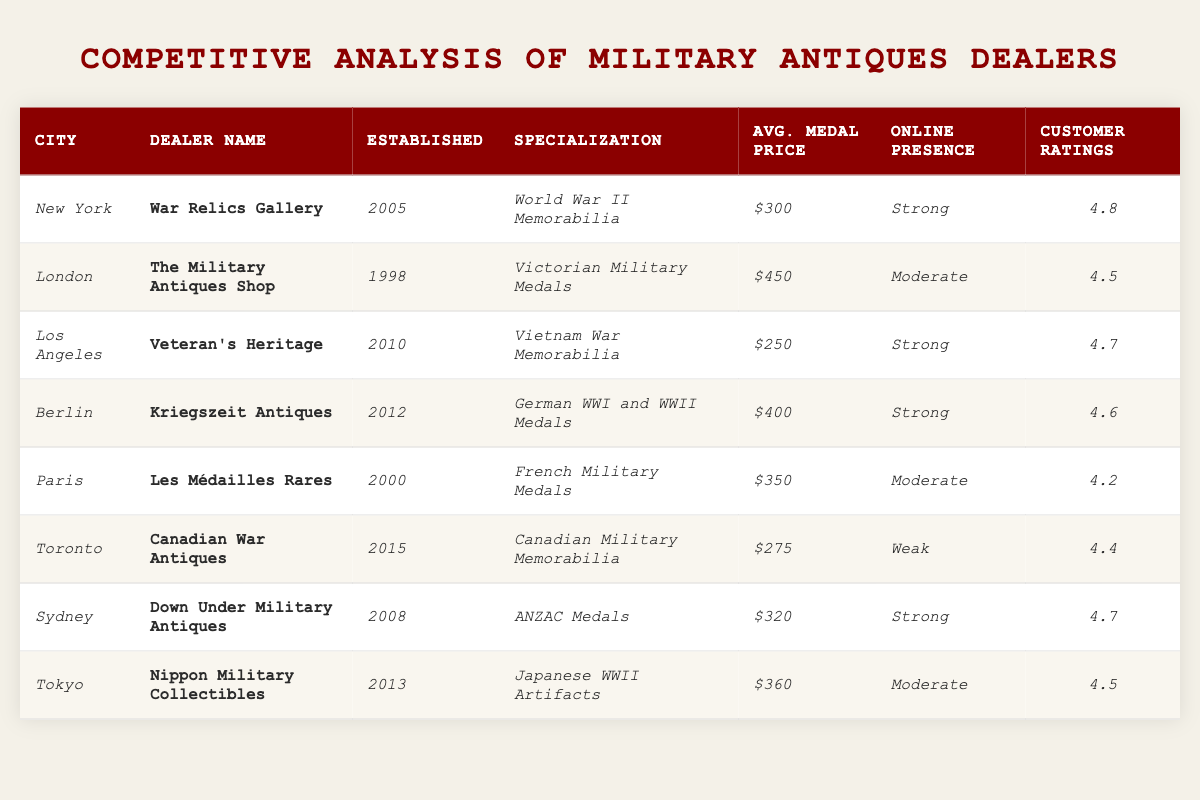What is the average price of medals across all dealers listed? To find the average price, first, we sum the average prices of all dealers: $300 + $450 + $250 + $400 + $350 + $275 + $320 + $360 = $2,685. Then, we divide this by the total number of dealers (8): $2,685 / 8 = $335.625, rounded to $336 when expressed in whole dollars.
Answer: $336 Which dealer has the highest customer ratings? By examining the customer ratings given for each dealer, we see that the highest rating is 4.8, which belongs to the War Relics Gallery in New York.
Answer: War Relics Gallery Is there a dealer specialized in Canadian Military Memorabilia? Yes, according to the table, the dealer specializing in Canadian Military Memorabilia is the Canadian War Antiques based in Toronto.
Answer: Yes How many dealers have a strong online presence? By counting the entries under the "Online Presence" column that mention "strong," we find that four dealers have a strong online presence: War Relics Gallery, Veteran's Heritage, Kriegszeit Antiques, and Down Under Military Antiques.
Answer: 4 Which city has the highest average medal price, and what is that price? Looking through the average prices, we find that London has the highest average medal price at $450 (as listed under The Military Antiques Shop).
Answer: London, $450 What is the difference in average medal prices between the highest and lowest priced medals? The highest average price is $450 from The Military Antiques Shop, and the lowest average price is $250 from Veteran's Heritage. The difference is calculated as $450 - $250 = $200.
Answer: $200 Which dealer was established most recently? By comparing the establishments dates, Canadian War Antiques was established in 2015, making it the most recently established dealer in the list.
Answer: Canadian War Antiques In which city does the dealer with the lowest average medal price operate? The dealer with the lowest average medal price is Veteran's Heritage with a price of $250, located in Los Angeles.
Answer: Los Angeles How many dealers have customer ratings of 4.5 or higher? We check the customer ratings and note those 4.5 or higher: War Relics Gallery (4.8), Veteran's Heritage (4.7), Kriegszeit Antiques (4.6), The Military Antiques Shop (4.5), and Nippon Military Collectibles (4.5). This gives us a total of five dealers.
Answer: 5 Which specialization is most commonly found among the dealers? By analyzing the specializations, we note that there are no repeated specializations, each dealer has a unique focus on different wars or types of memorabilia; hence, no specialization is common among them.
Answer: None 